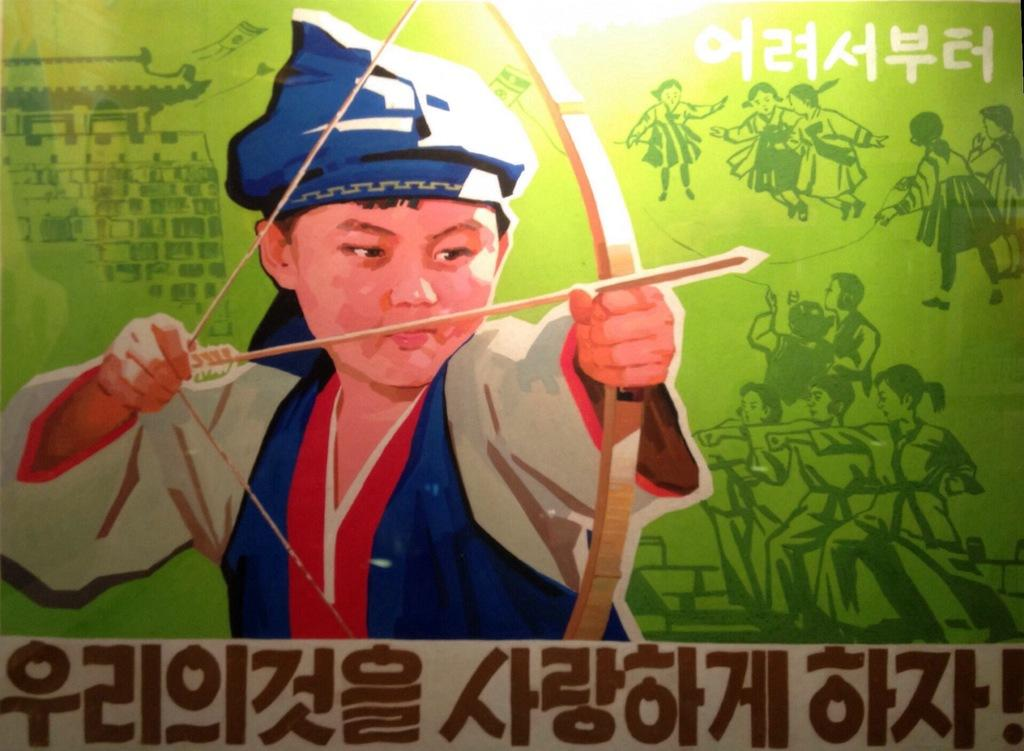What is the main object in the image? There is a banner in the image. What is shown on the banner? A child holding a bow and arrow is depicted on the banner. Are there any words or letters on the banner? Yes, there is text on the banner. Can you see a bear playing with a seed in the cellar in the image? No, there is no bear, seed, or cellar present in the image. The image only features a banner with a child holding a bow and arrow and text on it. 